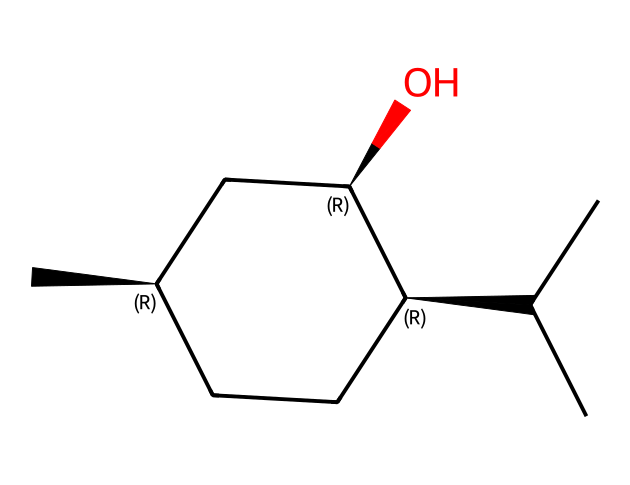What is the IUPAC name of this compound? The structure corresponds to menthol, which is a well-known compound. Its IUPAC name can be derived by analyzing the SMILES, identifying the chiral centers and the overall structure.
Answer: menthol How many chiral centers are present in menthol? By examining the structure, there are three carbon atoms that have four different substituents attached to them, which indicates three chiral centers.
Answer: 3 What is the functional group in menthol? The compound contains an alcohol functional group, which is identifiable by the presence of the hydroxyl (-OH) group attached to the carbon structure in the SMILES.
Answer: alcohol What is the molecular formula of menthol? Evaluating the structure reveals the count of carbon (C), hydrogen (H), and oxygen (O) atoms, leading us to conclude that the molecular formula is C10H20O.
Answer: C10H20O What type of isomerism does menthol exhibit? Considering menthol’s structure reveals it has chiral centers, thus it exhibits stereoisomerism, as it can exist as enantiomers due to the arrangement of its atoms.
Answer: stereoisomerism How many carbon atoms are in menthol? By counting the carbon (C) atoms represented in the structure visualized from the SMILES, it can be identified that there are ten carbon atoms.
Answer: 10 Which part of menthol gives it a cooling sensation? The presence of the hydroxyl (-OH) functional group interacts with receptors in the body, providing a cooling sensation when menthol is applied or consumed.
Answer: hydroxyl group 